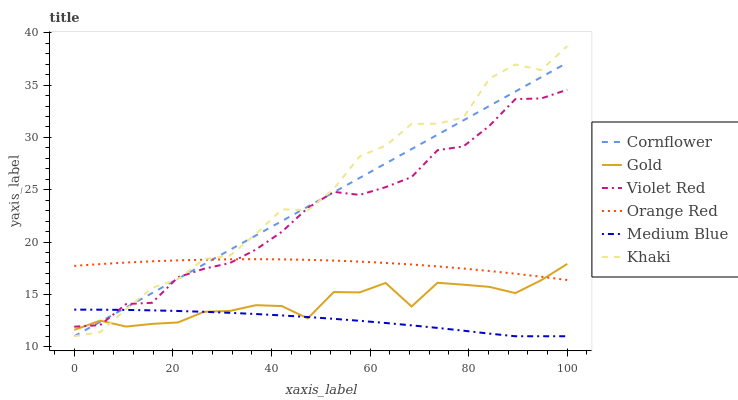Does Violet Red have the minimum area under the curve?
Answer yes or no. No. Does Violet Red have the maximum area under the curve?
Answer yes or no. No. Is Violet Red the smoothest?
Answer yes or no. No. Is Violet Red the roughest?
Answer yes or no. No. Does Violet Red have the lowest value?
Answer yes or no. No. Does Violet Red have the highest value?
Answer yes or no. No. Is Medium Blue less than Orange Red?
Answer yes or no. Yes. Is Orange Red greater than Medium Blue?
Answer yes or no. Yes. Does Medium Blue intersect Orange Red?
Answer yes or no. No. 